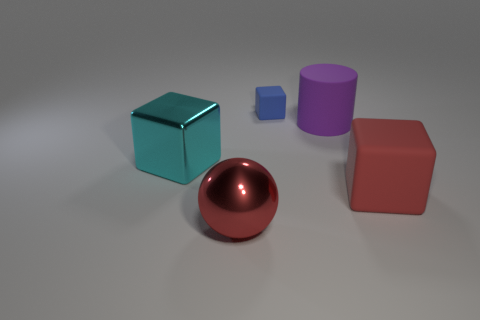Add 1 red rubber objects. How many objects exist? 6 Subtract all balls. How many objects are left? 4 Add 2 brown metal cylinders. How many brown metal cylinders exist? 2 Subtract 0 blue cylinders. How many objects are left? 5 Subtract all balls. Subtract all metallic cubes. How many objects are left? 3 Add 2 purple objects. How many purple objects are left? 3 